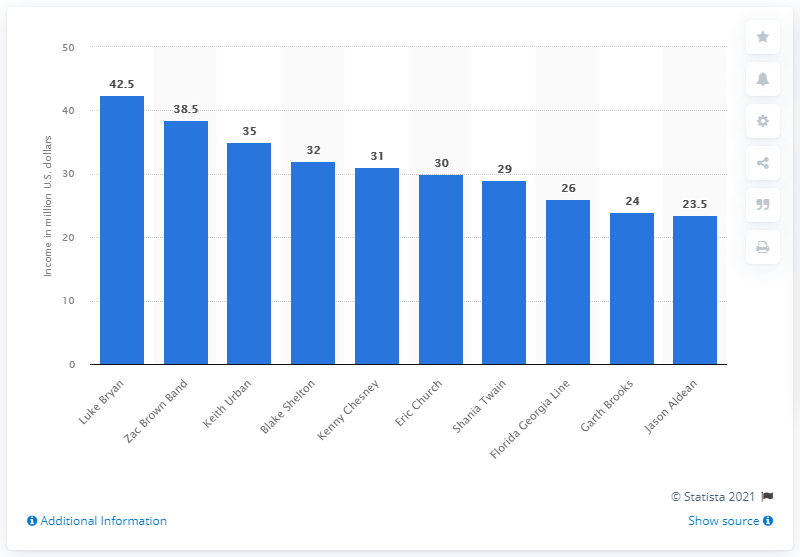Give some essential details in this illustration. According to the highest earning country music celebrities between June 2018 and June 2019, Kenny Chesney was the fifth highest paid. Zac Brown Band was the second highest paid country music artist between June 2018 and June 2019. During the period of June 2018 to June 2019, Kenny Chesney's annual income was approximately $31 million. Luke Bryan's annual income was approximately $42.5 million. 